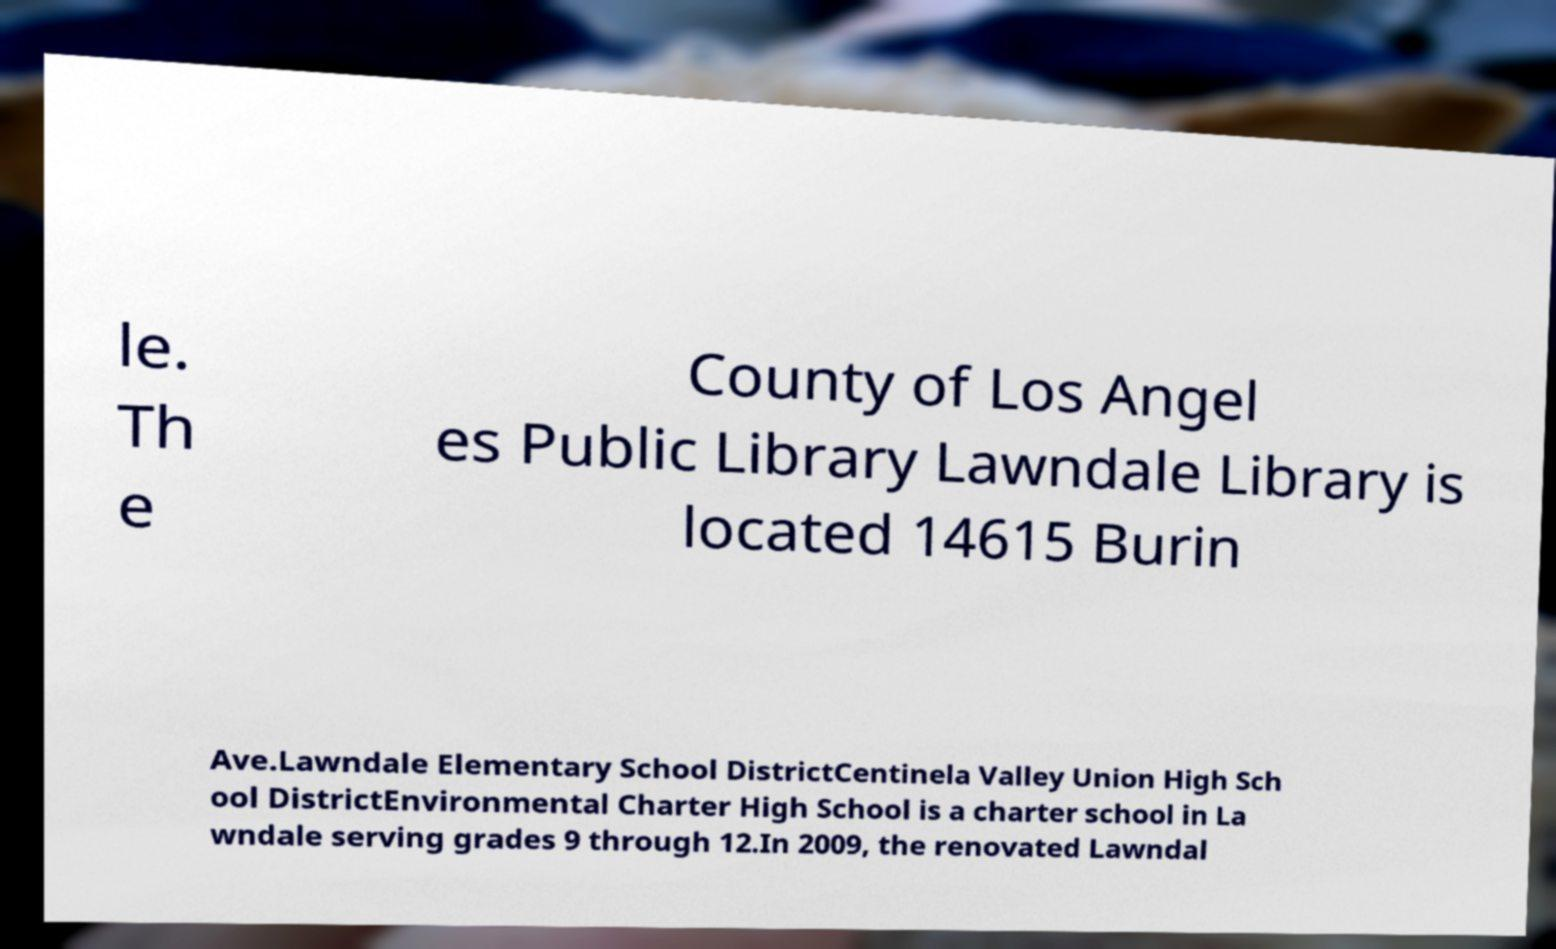Please read and relay the text visible in this image. What does it say? le. Th e County of Los Angel es Public Library Lawndale Library is located 14615 Burin Ave.Lawndale Elementary School DistrictCentinela Valley Union High Sch ool DistrictEnvironmental Charter High School is a charter school in La wndale serving grades 9 through 12.In 2009, the renovated Lawndal 